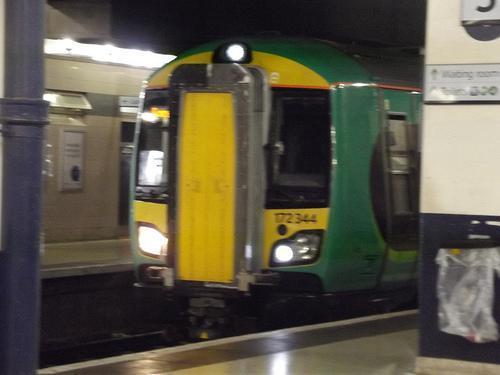How many trains are in the photo?
Give a very brief answer. 1. 